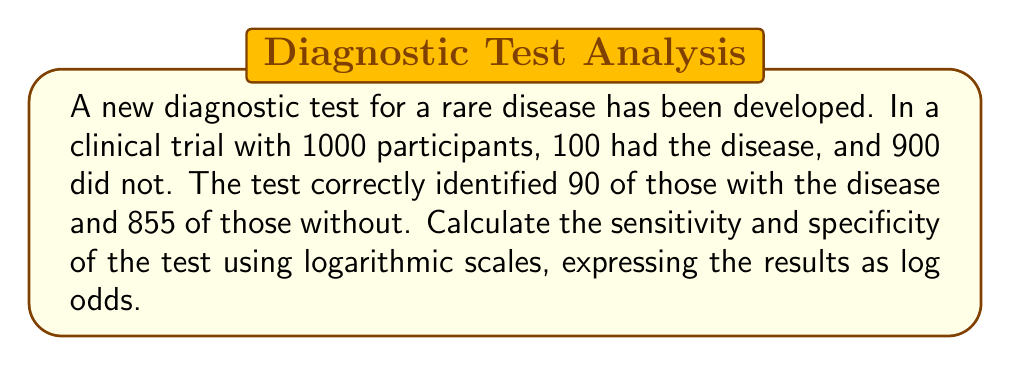Can you solve this math problem? Step 1: Calculate sensitivity and specificity
Sensitivity = True Positives / (True Positives + False Negatives)
Sensitivity = 90 / 100 = 0.90

Specificity = True Negatives / (True Negatives + False Positives)
Specificity = 855 / 900 = 0.95

Step 2: Convert sensitivity and specificity to odds
Odds(Sensitivity) = Sensitivity / (1 - Sensitivity) = 0.90 / 0.10 = 9
Odds(Specificity) = Specificity / (1 - Specificity) = 0.95 / 0.05 = 19

Step 3: Calculate log odds
Log odds(Sensitivity) = $\log(9)$
Log odds(Specificity) = $\log(19)$

Step 4: Use natural logarithm (ln) for calculation
Log odds(Sensitivity) = $\ln(9) \approx 2.1972$
Log odds(Specificity) = $\ln(19) \approx 2.9444$

Therefore, the sensitivity and specificity expressed as log odds are approximately 2.1972 and 2.9444, respectively.
Answer: Sensitivity (log odds): $\ln(9) \approx 2.1972$
Specificity (log odds): $\ln(19) \approx 2.9444$ 